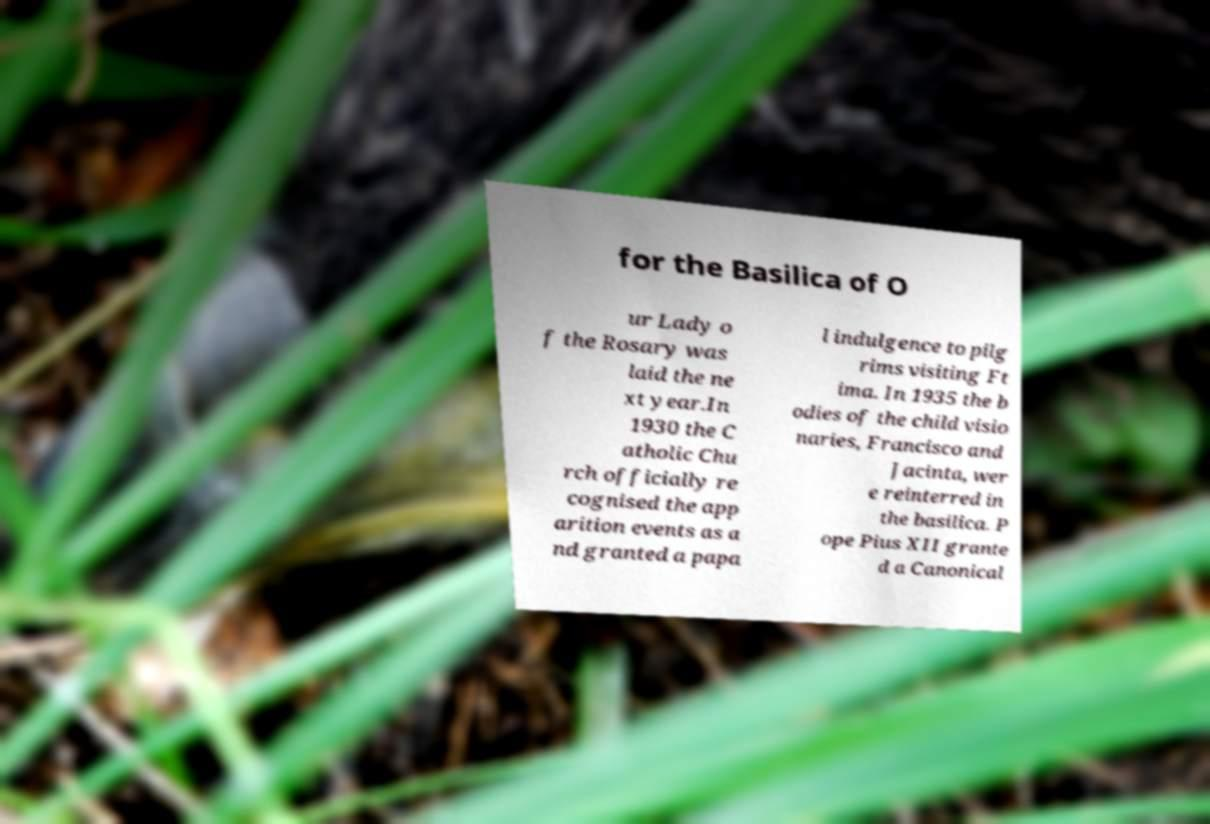Please read and relay the text visible in this image. What does it say? for the Basilica of O ur Lady o f the Rosary was laid the ne xt year.In 1930 the C atholic Chu rch officially re cognised the app arition events as a nd granted a papa l indulgence to pilg rims visiting Ft ima. In 1935 the b odies of the child visio naries, Francisco and Jacinta, wer e reinterred in the basilica. P ope Pius XII grante d a Canonical 